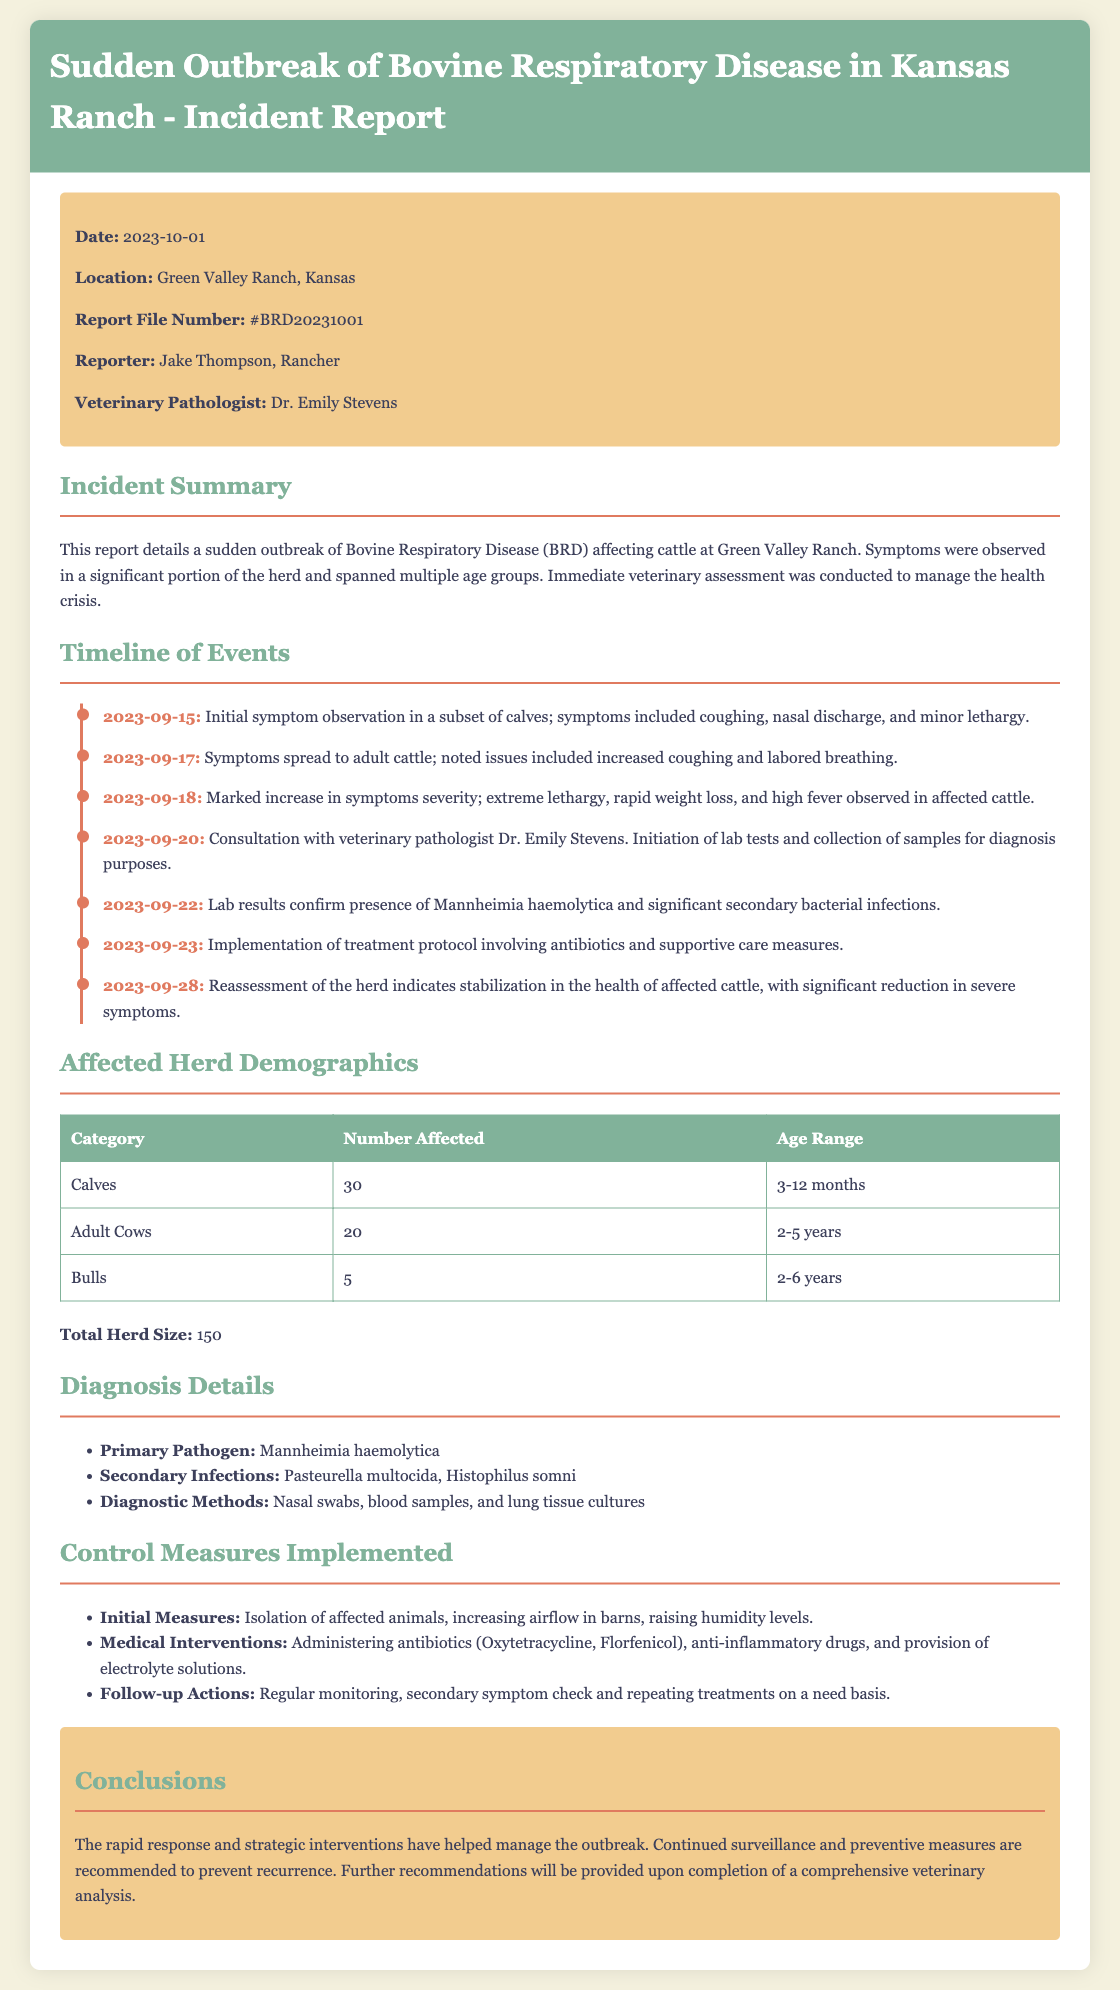what is the primary pathogen identified? The primary pathogen identified in the outbreak was stated as Mannheimia haemolytica.
Answer: Mannheimia haemolytica when did initial symptoms first appear? The initial symptoms were observed on September 15, 2023, in a subset of calves.
Answer: 2023-09-15 how many adult cows were affected? Affected demographics indicate that there were 20 adult cows affected.
Answer: 20 who was the veterinary pathologist involved? The report names Dr. Emily Stevens as the veterinary pathologist providing assistance during the outbreak.
Answer: Dr. Emily Stevens what treatment protocol was implemented on September 23? The treatment protocol included administering antibiotics and supportive care measures.
Answer: antibiotics and supportive care measures what was the total herd size? The total number of cattle in the herd is explicitly mentioned in the report.
Answer: 150 why is continued surveillance recommended? The report concludes that continued surveillance is crucial to prevent recurrence of the outbreak.
Answer: prevent recurrence what category of cattle had the highest number affected? The category with the highest number affected was calves, with 30 individuals noted in the report.
Answer: Calves what were the diagnostic methods used? The methods listed for diagnosis included nasal swabs, blood samples, and lung tissue cultures.
Answer: nasal swabs, blood samples, and lung tissue cultures 